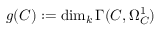<formula> <loc_0><loc_0><loc_500><loc_500>g ( C ) \colon = \dim _ { k } \Gamma ( C , \Omega _ { C } ^ { 1 } )</formula> 